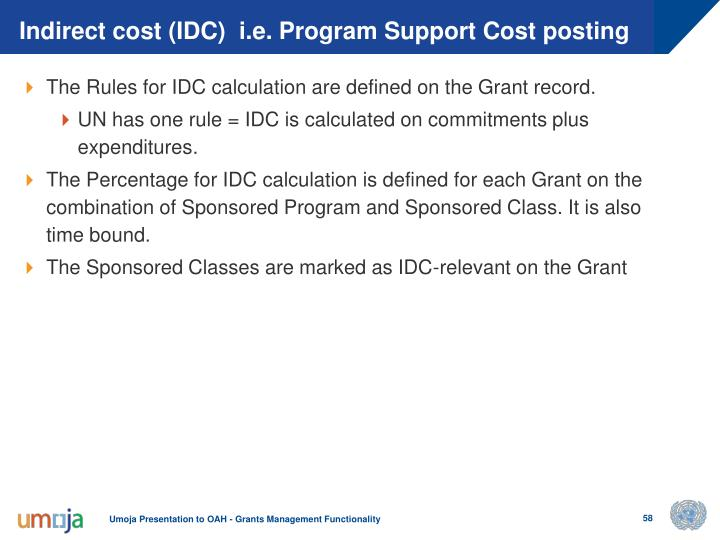Can you describe the type of information typically included in a presentation slide related to grant management, like the one displayed? This type of presentation slide typically includes key details about the rules and methods related to the management of grants, such as the calculation of indirect costs, commonly known as IDC. It outlines how these costs are determined according to specific rules and what percentage of the grant they pertain to. Additionally, slides may cover the importance of proper designation of Sponsored Classes and their time bounds within the grant structure to ensure proper financial tracking and accountability. 